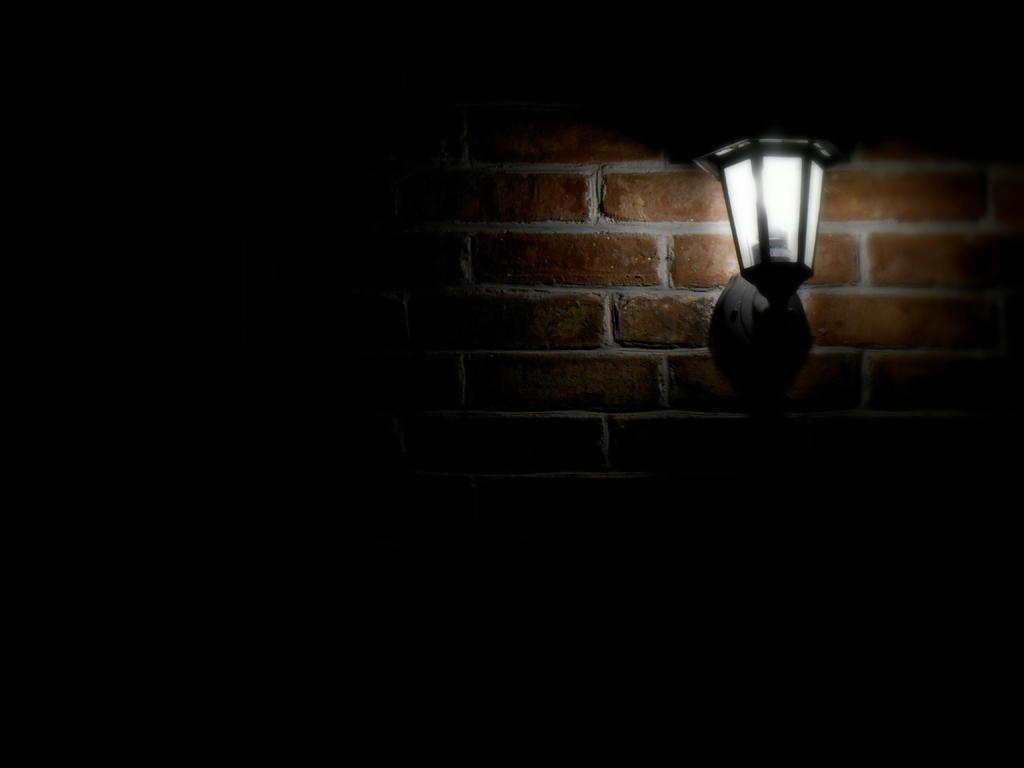What type of structure is visible in the picture? There is a brick wall in the picture. Is there anything attached to the brick wall? Yes, a light is fixed to the wall. How bright is the light in the picture? The illumination of the light is very low. What invention is being showcased in the picture? There is no invention being showcased in the picture; it simply features a brick wall with a light attached to it. What season is depicted in the picture? The season is not depicted in the picture, as there are no seasonal cues present. 